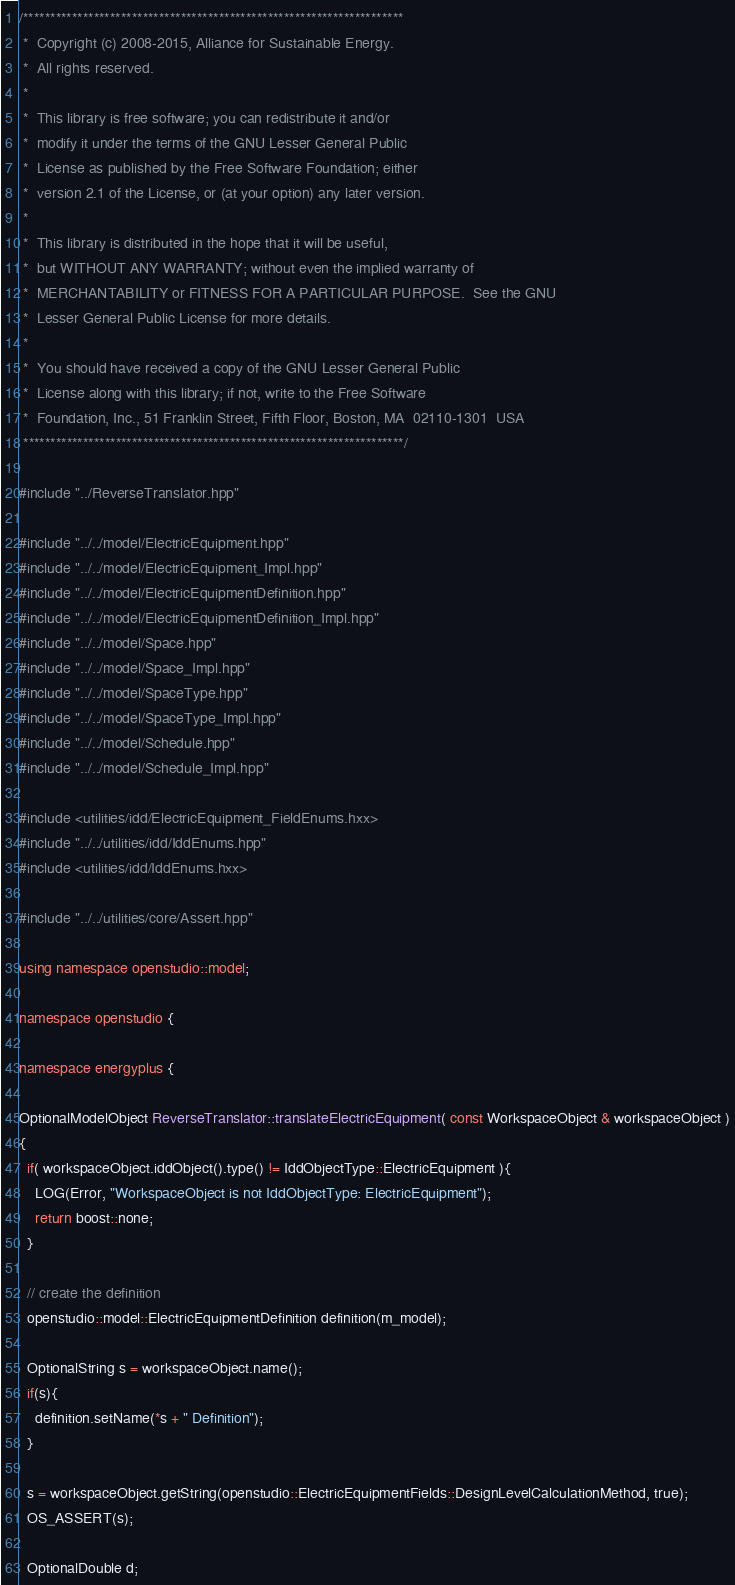<code> <loc_0><loc_0><loc_500><loc_500><_C++_>/**********************************************************************
 *  Copyright (c) 2008-2015, Alliance for Sustainable Energy.
 *  All rights reserved.
 *
 *  This library is free software; you can redistribute it and/or
 *  modify it under the terms of the GNU Lesser General Public
 *  License as published by the Free Software Foundation; either
 *  version 2.1 of the License, or (at your option) any later version.
 *
 *  This library is distributed in the hope that it will be useful,
 *  but WITHOUT ANY WARRANTY; without even the implied warranty of
 *  MERCHANTABILITY or FITNESS FOR A PARTICULAR PURPOSE.  See the GNU
 *  Lesser General Public License for more details.
 *
 *  You should have received a copy of the GNU Lesser General Public
 *  License along with this library; if not, write to the Free Software
 *  Foundation, Inc., 51 Franklin Street, Fifth Floor, Boston, MA  02110-1301  USA
 **********************************************************************/

#include "../ReverseTranslator.hpp"

#include "../../model/ElectricEquipment.hpp"
#include "../../model/ElectricEquipment_Impl.hpp"
#include "../../model/ElectricEquipmentDefinition.hpp"
#include "../../model/ElectricEquipmentDefinition_Impl.hpp"
#include "../../model/Space.hpp"
#include "../../model/Space_Impl.hpp"
#include "../../model/SpaceType.hpp"
#include "../../model/SpaceType_Impl.hpp"
#include "../../model/Schedule.hpp"
#include "../../model/Schedule_Impl.hpp"

#include <utilities/idd/ElectricEquipment_FieldEnums.hxx>
#include "../../utilities/idd/IddEnums.hpp"
#include <utilities/idd/IddEnums.hxx>

#include "../../utilities/core/Assert.hpp"

using namespace openstudio::model;

namespace openstudio {

namespace energyplus {

OptionalModelObject ReverseTranslator::translateElectricEquipment( const WorkspaceObject & workspaceObject )
{
  if( workspaceObject.iddObject().type() != IddObjectType::ElectricEquipment ){
    LOG(Error, "WorkspaceObject is not IddObjectType: ElectricEquipment");
    return boost::none;
  }

  // create the definition
  openstudio::model::ElectricEquipmentDefinition definition(m_model);
  
  OptionalString s = workspaceObject.name();
  if(s){
    definition.setName(*s + " Definition");
  }

  s = workspaceObject.getString(openstudio::ElectricEquipmentFields::DesignLevelCalculationMethod, true);
  OS_ASSERT(s);

  OptionalDouble d;</code> 